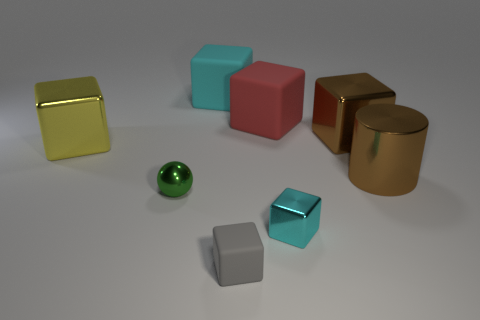There is a red matte thing that is the same size as the cylinder; what shape is it? cube 